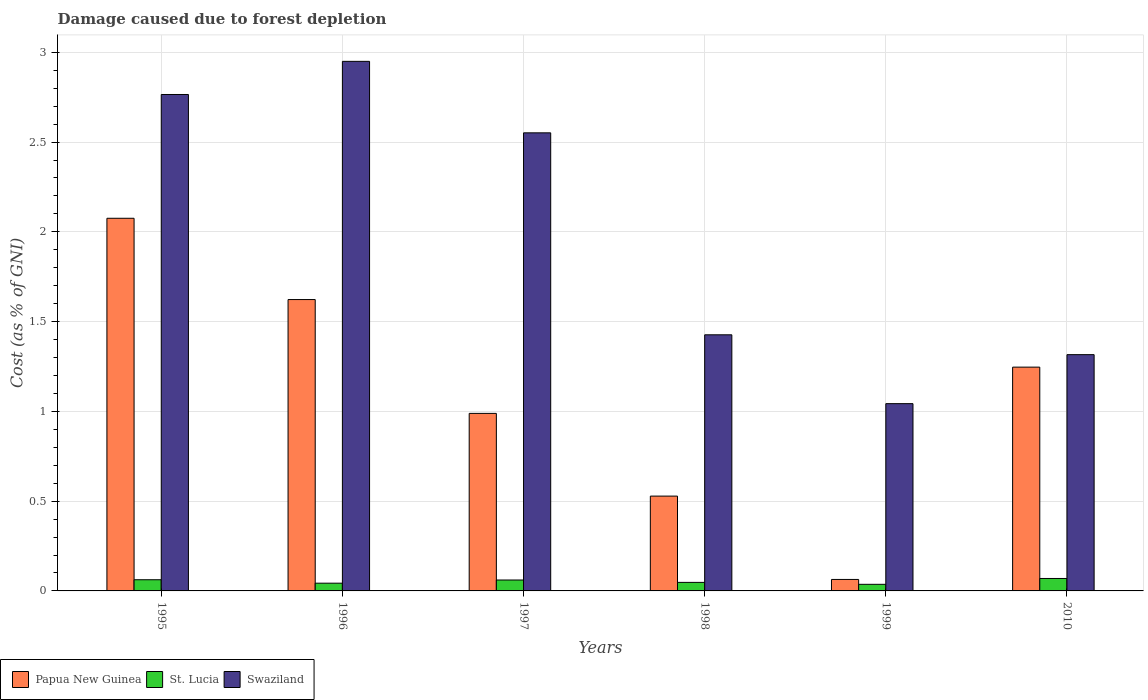How many different coloured bars are there?
Your answer should be compact. 3. How many groups of bars are there?
Keep it short and to the point. 6. Are the number of bars per tick equal to the number of legend labels?
Provide a short and direct response. Yes. How many bars are there on the 2nd tick from the left?
Your answer should be very brief. 3. How many bars are there on the 6th tick from the right?
Your answer should be compact. 3. What is the cost of damage caused due to forest depletion in Swaziland in 1997?
Give a very brief answer. 2.55. Across all years, what is the maximum cost of damage caused due to forest depletion in Swaziland?
Keep it short and to the point. 2.95. Across all years, what is the minimum cost of damage caused due to forest depletion in Swaziland?
Ensure brevity in your answer.  1.04. What is the total cost of damage caused due to forest depletion in Papua New Guinea in the graph?
Offer a very short reply. 6.53. What is the difference between the cost of damage caused due to forest depletion in Swaziland in 1996 and that in 1999?
Make the answer very short. 1.91. What is the difference between the cost of damage caused due to forest depletion in Swaziland in 1997 and the cost of damage caused due to forest depletion in Papua New Guinea in 1999?
Your response must be concise. 2.49. What is the average cost of damage caused due to forest depletion in St. Lucia per year?
Make the answer very short. 0.05. In the year 1996, what is the difference between the cost of damage caused due to forest depletion in Papua New Guinea and cost of damage caused due to forest depletion in Swaziland?
Provide a short and direct response. -1.33. In how many years, is the cost of damage caused due to forest depletion in Swaziland greater than 0.30000000000000004 %?
Provide a short and direct response. 6. What is the ratio of the cost of damage caused due to forest depletion in St. Lucia in 1998 to that in 2010?
Keep it short and to the point. 0.69. Is the cost of damage caused due to forest depletion in St. Lucia in 1997 less than that in 1999?
Keep it short and to the point. No. Is the difference between the cost of damage caused due to forest depletion in Papua New Guinea in 1995 and 1996 greater than the difference between the cost of damage caused due to forest depletion in Swaziland in 1995 and 1996?
Keep it short and to the point. Yes. What is the difference between the highest and the second highest cost of damage caused due to forest depletion in Swaziland?
Make the answer very short. 0.18. What is the difference between the highest and the lowest cost of damage caused due to forest depletion in Swaziland?
Your answer should be very brief. 1.91. In how many years, is the cost of damage caused due to forest depletion in Papua New Guinea greater than the average cost of damage caused due to forest depletion in Papua New Guinea taken over all years?
Make the answer very short. 3. Is the sum of the cost of damage caused due to forest depletion in St. Lucia in 1995 and 1996 greater than the maximum cost of damage caused due to forest depletion in Papua New Guinea across all years?
Offer a very short reply. No. What does the 2nd bar from the left in 1995 represents?
Your response must be concise. St. Lucia. What does the 1st bar from the right in 1996 represents?
Provide a short and direct response. Swaziland. How many bars are there?
Give a very brief answer. 18. What is the difference between two consecutive major ticks on the Y-axis?
Give a very brief answer. 0.5. Does the graph contain any zero values?
Provide a succinct answer. No. Does the graph contain grids?
Offer a very short reply. Yes. How are the legend labels stacked?
Provide a succinct answer. Horizontal. What is the title of the graph?
Your response must be concise. Damage caused due to forest depletion. What is the label or title of the Y-axis?
Provide a succinct answer. Cost (as % of GNI). What is the Cost (as % of GNI) in Papua New Guinea in 1995?
Your answer should be compact. 2.08. What is the Cost (as % of GNI) of St. Lucia in 1995?
Provide a short and direct response. 0.06. What is the Cost (as % of GNI) in Swaziland in 1995?
Ensure brevity in your answer.  2.77. What is the Cost (as % of GNI) in Papua New Guinea in 1996?
Ensure brevity in your answer.  1.62. What is the Cost (as % of GNI) of St. Lucia in 1996?
Provide a short and direct response. 0.04. What is the Cost (as % of GNI) in Swaziland in 1996?
Give a very brief answer. 2.95. What is the Cost (as % of GNI) of Papua New Guinea in 1997?
Ensure brevity in your answer.  0.99. What is the Cost (as % of GNI) of St. Lucia in 1997?
Offer a very short reply. 0.06. What is the Cost (as % of GNI) in Swaziland in 1997?
Provide a succinct answer. 2.55. What is the Cost (as % of GNI) in Papua New Guinea in 1998?
Your answer should be very brief. 0.53. What is the Cost (as % of GNI) of St. Lucia in 1998?
Give a very brief answer. 0.05. What is the Cost (as % of GNI) in Swaziland in 1998?
Ensure brevity in your answer.  1.43. What is the Cost (as % of GNI) of Papua New Guinea in 1999?
Your answer should be compact. 0.06. What is the Cost (as % of GNI) in St. Lucia in 1999?
Your answer should be compact. 0.04. What is the Cost (as % of GNI) in Swaziland in 1999?
Offer a very short reply. 1.04. What is the Cost (as % of GNI) in Papua New Guinea in 2010?
Your answer should be very brief. 1.25. What is the Cost (as % of GNI) in St. Lucia in 2010?
Your response must be concise. 0.07. What is the Cost (as % of GNI) of Swaziland in 2010?
Offer a terse response. 1.32. Across all years, what is the maximum Cost (as % of GNI) of Papua New Guinea?
Your answer should be compact. 2.08. Across all years, what is the maximum Cost (as % of GNI) in St. Lucia?
Offer a terse response. 0.07. Across all years, what is the maximum Cost (as % of GNI) in Swaziland?
Your answer should be compact. 2.95. Across all years, what is the minimum Cost (as % of GNI) of Papua New Guinea?
Your answer should be compact. 0.06. Across all years, what is the minimum Cost (as % of GNI) of St. Lucia?
Offer a very short reply. 0.04. Across all years, what is the minimum Cost (as % of GNI) of Swaziland?
Your answer should be compact. 1.04. What is the total Cost (as % of GNI) in Papua New Guinea in the graph?
Your response must be concise. 6.53. What is the total Cost (as % of GNI) in St. Lucia in the graph?
Make the answer very short. 0.32. What is the total Cost (as % of GNI) in Swaziland in the graph?
Provide a short and direct response. 12.05. What is the difference between the Cost (as % of GNI) of Papua New Guinea in 1995 and that in 1996?
Provide a succinct answer. 0.45. What is the difference between the Cost (as % of GNI) in St. Lucia in 1995 and that in 1996?
Keep it short and to the point. 0.02. What is the difference between the Cost (as % of GNI) of Swaziland in 1995 and that in 1996?
Provide a succinct answer. -0.18. What is the difference between the Cost (as % of GNI) in Papua New Guinea in 1995 and that in 1997?
Make the answer very short. 1.09. What is the difference between the Cost (as % of GNI) in St. Lucia in 1995 and that in 1997?
Make the answer very short. 0. What is the difference between the Cost (as % of GNI) of Swaziland in 1995 and that in 1997?
Offer a very short reply. 0.21. What is the difference between the Cost (as % of GNI) of Papua New Guinea in 1995 and that in 1998?
Offer a terse response. 1.55. What is the difference between the Cost (as % of GNI) of St. Lucia in 1995 and that in 1998?
Ensure brevity in your answer.  0.01. What is the difference between the Cost (as % of GNI) of Swaziland in 1995 and that in 1998?
Offer a terse response. 1.34. What is the difference between the Cost (as % of GNI) of Papua New Guinea in 1995 and that in 1999?
Offer a very short reply. 2.01. What is the difference between the Cost (as % of GNI) in St. Lucia in 1995 and that in 1999?
Offer a terse response. 0.03. What is the difference between the Cost (as % of GNI) of Swaziland in 1995 and that in 1999?
Give a very brief answer. 1.72. What is the difference between the Cost (as % of GNI) in Papua New Guinea in 1995 and that in 2010?
Your answer should be compact. 0.83. What is the difference between the Cost (as % of GNI) of St. Lucia in 1995 and that in 2010?
Offer a very short reply. -0.01. What is the difference between the Cost (as % of GNI) of Swaziland in 1995 and that in 2010?
Offer a terse response. 1.45. What is the difference between the Cost (as % of GNI) in Papua New Guinea in 1996 and that in 1997?
Ensure brevity in your answer.  0.63. What is the difference between the Cost (as % of GNI) of St. Lucia in 1996 and that in 1997?
Your response must be concise. -0.02. What is the difference between the Cost (as % of GNI) in Swaziland in 1996 and that in 1997?
Offer a very short reply. 0.4. What is the difference between the Cost (as % of GNI) in Papua New Guinea in 1996 and that in 1998?
Offer a very short reply. 1.09. What is the difference between the Cost (as % of GNI) of St. Lucia in 1996 and that in 1998?
Offer a very short reply. -0. What is the difference between the Cost (as % of GNI) of Swaziland in 1996 and that in 1998?
Offer a very short reply. 1.52. What is the difference between the Cost (as % of GNI) in Papua New Guinea in 1996 and that in 1999?
Provide a short and direct response. 1.56. What is the difference between the Cost (as % of GNI) of St. Lucia in 1996 and that in 1999?
Provide a short and direct response. 0.01. What is the difference between the Cost (as % of GNI) in Swaziland in 1996 and that in 1999?
Provide a succinct answer. 1.91. What is the difference between the Cost (as % of GNI) of Papua New Guinea in 1996 and that in 2010?
Your answer should be very brief. 0.38. What is the difference between the Cost (as % of GNI) in St. Lucia in 1996 and that in 2010?
Make the answer very short. -0.03. What is the difference between the Cost (as % of GNI) in Swaziland in 1996 and that in 2010?
Your answer should be compact. 1.63. What is the difference between the Cost (as % of GNI) of Papua New Guinea in 1997 and that in 1998?
Your answer should be compact. 0.46. What is the difference between the Cost (as % of GNI) in St. Lucia in 1997 and that in 1998?
Keep it short and to the point. 0.01. What is the difference between the Cost (as % of GNI) in Swaziland in 1997 and that in 1998?
Ensure brevity in your answer.  1.12. What is the difference between the Cost (as % of GNI) in Papua New Guinea in 1997 and that in 1999?
Make the answer very short. 0.92. What is the difference between the Cost (as % of GNI) of St. Lucia in 1997 and that in 1999?
Your answer should be very brief. 0.02. What is the difference between the Cost (as % of GNI) of Swaziland in 1997 and that in 1999?
Your response must be concise. 1.51. What is the difference between the Cost (as % of GNI) of Papua New Guinea in 1997 and that in 2010?
Your answer should be compact. -0.26. What is the difference between the Cost (as % of GNI) of St. Lucia in 1997 and that in 2010?
Provide a short and direct response. -0.01. What is the difference between the Cost (as % of GNI) of Swaziland in 1997 and that in 2010?
Provide a succinct answer. 1.24. What is the difference between the Cost (as % of GNI) of Papua New Guinea in 1998 and that in 1999?
Provide a short and direct response. 0.46. What is the difference between the Cost (as % of GNI) in St. Lucia in 1998 and that in 1999?
Provide a succinct answer. 0.01. What is the difference between the Cost (as % of GNI) of Swaziland in 1998 and that in 1999?
Ensure brevity in your answer.  0.38. What is the difference between the Cost (as % of GNI) in Papua New Guinea in 1998 and that in 2010?
Ensure brevity in your answer.  -0.72. What is the difference between the Cost (as % of GNI) in St. Lucia in 1998 and that in 2010?
Provide a short and direct response. -0.02. What is the difference between the Cost (as % of GNI) of Swaziland in 1998 and that in 2010?
Keep it short and to the point. 0.11. What is the difference between the Cost (as % of GNI) in Papua New Guinea in 1999 and that in 2010?
Keep it short and to the point. -1.18. What is the difference between the Cost (as % of GNI) in St. Lucia in 1999 and that in 2010?
Ensure brevity in your answer.  -0.03. What is the difference between the Cost (as % of GNI) in Swaziland in 1999 and that in 2010?
Make the answer very short. -0.27. What is the difference between the Cost (as % of GNI) of Papua New Guinea in 1995 and the Cost (as % of GNI) of St. Lucia in 1996?
Give a very brief answer. 2.03. What is the difference between the Cost (as % of GNI) of Papua New Guinea in 1995 and the Cost (as % of GNI) of Swaziland in 1996?
Your response must be concise. -0.87. What is the difference between the Cost (as % of GNI) in St. Lucia in 1995 and the Cost (as % of GNI) in Swaziland in 1996?
Offer a very short reply. -2.89. What is the difference between the Cost (as % of GNI) in Papua New Guinea in 1995 and the Cost (as % of GNI) in St. Lucia in 1997?
Give a very brief answer. 2.01. What is the difference between the Cost (as % of GNI) in Papua New Guinea in 1995 and the Cost (as % of GNI) in Swaziland in 1997?
Your answer should be compact. -0.48. What is the difference between the Cost (as % of GNI) in St. Lucia in 1995 and the Cost (as % of GNI) in Swaziland in 1997?
Your response must be concise. -2.49. What is the difference between the Cost (as % of GNI) of Papua New Guinea in 1995 and the Cost (as % of GNI) of St. Lucia in 1998?
Your answer should be compact. 2.03. What is the difference between the Cost (as % of GNI) in Papua New Guinea in 1995 and the Cost (as % of GNI) in Swaziland in 1998?
Give a very brief answer. 0.65. What is the difference between the Cost (as % of GNI) in St. Lucia in 1995 and the Cost (as % of GNI) in Swaziland in 1998?
Your answer should be very brief. -1.36. What is the difference between the Cost (as % of GNI) in Papua New Guinea in 1995 and the Cost (as % of GNI) in St. Lucia in 1999?
Make the answer very short. 2.04. What is the difference between the Cost (as % of GNI) in Papua New Guinea in 1995 and the Cost (as % of GNI) in Swaziland in 1999?
Give a very brief answer. 1.03. What is the difference between the Cost (as % of GNI) of St. Lucia in 1995 and the Cost (as % of GNI) of Swaziland in 1999?
Keep it short and to the point. -0.98. What is the difference between the Cost (as % of GNI) in Papua New Guinea in 1995 and the Cost (as % of GNI) in St. Lucia in 2010?
Keep it short and to the point. 2.01. What is the difference between the Cost (as % of GNI) of Papua New Guinea in 1995 and the Cost (as % of GNI) of Swaziland in 2010?
Your answer should be compact. 0.76. What is the difference between the Cost (as % of GNI) in St. Lucia in 1995 and the Cost (as % of GNI) in Swaziland in 2010?
Your answer should be compact. -1.25. What is the difference between the Cost (as % of GNI) of Papua New Guinea in 1996 and the Cost (as % of GNI) of St. Lucia in 1997?
Offer a terse response. 1.56. What is the difference between the Cost (as % of GNI) in Papua New Guinea in 1996 and the Cost (as % of GNI) in Swaziland in 1997?
Your response must be concise. -0.93. What is the difference between the Cost (as % of GNI) of St. Lucia in 1996 and the Cost (as % of GNI) of Swaziland in 1997?
Offer a very short reply. -2.51. What is the difference between the Cost (as % of GNI) of Papua New Guinea in 1996 and the Cost (as % of GNI) of St. Lucia in 1998?
Make the answer very short. 1.58. What is the difference between the Cost (as % of GNI) of Papua New Guinea in 1996 and the Cost (as % of GNI) of Swaziland in 1998?
Provide a short and direct response. 0.2. What is the difference between the Cost (as % of GNI) in St. Lucia in 1996 and the Cost (as % of GNI) in Swaziland in 1998?
Provide a succinct answer. -1.38. What is the difference between the Cost (as % of GNI) of Papua New Guinea in 1996 and the Cost (as % of GNI) of St. Lucia in 1999?
Your response must be concise. 1.59. What is the difference between the Cost (as % of GNI) of Papua New Guinea in 1996 and the Cost (as % of GNI) of Swaziland in 1999?
Your answer should be compact. 0.58. What is the difference between the Cost (as % of GNI) of Papua New Guinea in 1996 and the Cost (as % of GNI) of St. Lucia in 2010?
Keep it short and to the point. 1.55. What is the difference between the Cost (as % of GNI) in Papua New Guinea in 1996 and the Cost (as % of GNI) in Swaziland in 2010?
Make the answer very short. 0.31. What is the difference between the Cost (as % of GNI) in St. Lucia in 1996 and the Cost (as % of GNI) in Swaziland in 2010?
Provide a succinct answer. -1.27. What is the difference between the Cost (as % of GNI) of Papua New Guinea in 1997 and the Cost (as % of GNI) of St. Lucia in 1998?
Provide a short and direct response. 0.94. What is the difference between the Cost (as % of GNI) in Papua New Guinea in 1997 and the Cost (as % of GNI) in Swaziland in 1998?
Give a very brief answer. -0.44. What is the difference between the Cost (as % of GNI) in St. Lucia in 1997 and the Cost (as % of GNI) in Swaziland in 1998?
Offer a terse response. -1.37. What is the difference between the Cost (as % of GNI) of Papua New Guinea in 1997 and the Cost (as % of GNI) of St. Lucia in 1999?
Your response must be concise. 0.95. What is the difference between the Cost (as % of GNI) in Papua New Guinea in 1997 and the Cost (as % of GNI) in Swaziland in 1999?
Your answer should be very brief. -0.05. What is the difference between the Cost (as % of GNI) in St. Lucia in 1997 and the Cost (as % of GNI) in Swaziland in 1999?
Your answer should be very brief. -0.98. What is the difference between the Cost (as % of GNI) of Papua New Guinea in 1997 and the Cost (as % of GNI) of St. Lucia in 2010?
Provide a succinct answer. 0.92. What is the difference between the Cost (as % of GNI) in Papua New Guinea in 1997 and the Cost (as % of GNI) in Swaziland in 2010?
Your answer should be compact. -0.33. What is the difference between the Cost (as % of GNI) of St. Lucia in 1997 and the Cost (as % of GNI) of Swaziland in 2010?
Keep it short and to the point. -1.26. What is the difference between the Cost (as % of GNI) of Papua New Guinea in 1998 and the Cost (as % of GNI) of St. Lucia in 1999?
Ensure brevity in your answer.  0.49. What is the difference between the Cost (as % of GNI) in Papua New Guinea in 1998 and the Cost (as % of GNI) in Swaziland in 1999?
Your response must be concise. -0.51. What is the difference between the Cost (as % of GNI) in St. Lucia in 1998 and the Cost (as % of GNI) in Swaziland in 1999?
Make the answer very short. -1. What is the difference between the Cost (as % of GNI) in Papua New Guinea in 1998 and the Cost (as % of GNI) in St. Lucia in 2010?
Ensure brevity in your answer.  0.46. What is the difference between the Cost (as % of GNI) of Papua New Guinea in 1998 and the Cost (as % of GNI) of Swaziland in 2010?
Ensure brevity in your answer.  -0.79. What is the difference between the Cost (as % of GNI) of St. Lucia in 1998 and the Cost (as % of GNI) of Swaziland in 2010?
Ensure brevity in your answer.  -1.27. What is the difference between the Cost (as % of GNI) of Papua New Guinea in 1999 and the Cost (as % of GNI) of St. Lucia in 2010?
Provide a short and direct response. -0.01. What is the difference between the Cost (as % of GNI) in Papua New Guinea in 1999 and the Cost (as % of GNI) in Swaziland in 2010?
Keep it short and to the point. -1.25. What is the difference between the Cost (as % of GNI) in St. Lucia in 1999 and the Cost (as % of GNI) in Swaziland in 2010?
Your answer should be very brief. -1.28. What is the average Cost (as % of GNI) of Papua New Guinea per year?
Your answer should be very brief. 1.09. What is the average Cost (as % of GNI) of St. Lucia per year?
Your response must be concise. 0.05. What is the average Cost (as % of GNI) of Swaziland per year?
Keep it short and to the point. 2.01. In the year 1995, what is the difference between the Cost (as % of GNI) of Papua New Guinea and Cost (as % of GNI) of St. Lucia?
Give a very brief answer. 2.01. In the year 1995, what is the difference between the Cost (as % of GNI) of Papua New Guinea and Cost (as % of GNI) of Swaziland?
Give a very brief answer. -0.69. In the year 1995, what is the difference between the Cost (as % of GNI) in St. Lucia and Cost (as % of GNI) in Swaziland?
Make the answer very short. -2.7. In the year 1996, what is the difference between the Cost (as % of GNI) in Papua New Guinea and Cost (as % of GNI) in St. Lucia?
Offer a terse response. 1.58. In the year 1996, what is the difference between the Cost (as % of GNI) of Papua New Guinea and Cost (as % of GNI) of Swaziland?
Offer a terse response. -1.33. In the year 1996, what is the difference between the Cost (as % of GNI) in St. Lucia and Cost (as % of GNI) in Swaziland?
Your answer should be compact. -2.91. In the year 1997, what is the difference between the Cost (as % of GNI) of Papua New Guinea and Cost (as % of GNI) of St. Lucia?
Make the answer very short. 0.93. In the year 1997, what is the difference between the Cost (as % of GNI) in Papua New Guinea and Cost (as % of GNI) in Swaziland?
Give a very brief answer. -1.56. In the year 1997, what is the difference between the Cost (as % of GNI) in St. Lucia and Cost (as % of GNI) in Swaziland?
Your answer should be very brief. -2.49. In the year 1998, what is the difference between the Cost (as % of GNI) of Papua New Guinea and Cost (as % of GNI) of St. Lucia?
Provide a succinct answer. 0.48. In the year 1998, what is the difference between the Cost (as % of GNI) of Papua New Guinea and Cost (as % of GNI) of Swaziland?
Offer a terse response. -0.9. In the year 1998, what is the difference between the Cost (as % of GNI) of St. Lucia and Cost (as % of GNI) of Swaziland?
Make the answer very short. -1.38. In the year 1999, what is the difference between the Cost (as % of GNI) in Papua New Guinea and Cost (as % of GNI) in St. Lucia?
Ensure brevity in your answer.  0.03. In the year 1999, what is the difference between the Cost (as % of GNI) in Papua New Guinea and Cost (as % of GNI) in Swaziland?
Offer a terse response. -0.98. In the year 1999, what is the difference between the Cost (as % of GNI) of St. Lucia and Cost (as % of GNI) of Swaziland?
Offer a terse response. -1.01. In the year 2010, what is the difference between the Cost (as % of GNI) in Papua New Guinea and Cost (as % of GNI) in St. Lucia?
Offer a very short reply. 1.18. In the year 2010, what is the difference between the Cost (as % of GNI) of Papua New Guinea and Cost (as % of GNI) of Swaziland?
Make the answer very short. -0.07. In the year 2010, what is the difference between the Cost (as % of GNI) of St. Lucia and Cost (as % of GNI) of Swaziland?
Provide a succinct answer. -1.25. What is the ratio of the Cost (as % of GNI) in Papua New Guinea in 1995 to that in 1996?
Make the answer very short. 1.28. What is the ratio of the Cost (as % of GNI) of St. Lucia in 1995 to that in 1996?
Your answer should be compact. 1.44. What is the ratio of the Cost (as % of GNI) in Swaziland in 1995 to that in 1996?
Provide a succinct answer. 0.94. What is the ratio of the Cost (as % of GNI) of Papua New Guinea in 1995 to that in 1997?
Ensure brevity in your answer.  2.1. What is the ratio of the Cost (as % of GNI) of St. Lucia in 1995 to that in 1997?
Give a very brief answer. 1.02. What is the ratio of the Cost (as % of GNI) in Swaziland in 1995 to that in 1997?
Keep it short and to the point. 1.08. What is the ratio of the Cost (as % of GNI) in Papua New Guinea in 1995 to that in 1998?
Give a very brief answer. 3.93. What is the ratio of the Cost (as % of GNI) of St. Lucia in 1995 to that in 1998?
Keep it short and to the point. 1.31. What is the ratio of the Cost (as % of GNI) of Swaziland in 1995 to that in 1998?
Your response must be concise. 1.94. What is the ratio of the Cost (as % of GNI) of Papua New Guinea in 1995 to that in 1999?
Provide a succinct answer. 32.46. What is the ratio of the Cost (as % of GNI) in St. Lucia in 1995 to that in 1999?
Offer a very short reply. 1.69. What is the ratio of the Cost (as % of GNI) in Swaziland in 1995 to that in 1999?
Your response must be concise. 2.65. What is the ratio of the Cost (as % of GNI) in Papua New Guinea in 1995 to that in 2010?
Ensure brevity in your answer.  1.67. What is the ratio of the Cost (as % of GNI) in St. Lucia in 1995 to that in 2010?
Give a very brief answer. 0.9. What is the ratio of the Cost (as % of GNI) of Swaziland in 1995 to that in 2010?
Provide a short and direct response. 2.1. What is the ratio of the Cost (as % of GNI) of Papua New Guinea in 1996 to that in 1997?
Your answer should be very brief. 1.64. What is the ratio of the Cost (as % of GNI) in St. Lucia in 1996 to that in 1997?
Keep it short and to the point. 0.71. What is the ratio of the Cost (as % of GNI) in Swaziland in 1996 to that in 1997?
Offer a terse response. 1.16. What is the ratio of the Cost (as % of GNI) in Papua New Guinea in 1996 to that in 1998?
Offer a terse response. 3.07. What is the ratio of the Cost (as % of GNI) in St. Lucia in 1996 to that in 1998?
Provide a succinct answer. 0.91. What is the ratio of the Cost (as % of GNI) of Swaziland in 1996 to that in 1998?
Your answer should be compact. 2.07. What is the ratio of the Cost (as % of GNI) of Papua New Guinea in 1996 to that in 1999?
Provide a succinct answer. 25.38. What is the ratio of the Cost (as % of GNI) in St. Lucia in 1996 to that in 1999?
Ensure brevity in your answer.  1.17. What is the ratio of the Cost (as % of GNI) of Swaziland in 1996 to that in 1999?
Offer a very short reply. 2.83. What is the ratio of the Cost (as % of GNI) of Papua New Guinea in 1996 to that in 2010?
Your response must be concise. 1.3. What is the ratio of the Cost (as % of GNI) of St. Lucia in 1996 to that in 2010?
Your answer should be very brief. 0.62. What is the ratio of the Cost (as % of GNI) of Swaziland in 1996 to that in 2010?
Your answer should be compact. 2.24. What is the ratio of the Cost (as % of GNI) of Papua New Guinea in 1997 to that in 1998?
Make the answer very short. 1.87. What is the ratio of the Cost (as % of GNI) in St. Lucia in 1997 to that in 1998?
Your answer should be very brief. 1.28. What is the ratio of the Cost (as % of GNI) in Swaziland in 1997 to that in 1998?
Make the answer very short. 1.79. What is the ratio of the Cost (as % of GNI) of Papua New Guinea in 1997 to that in 1999?
Give a very brief answer. 15.46. What is the ratio of the Cost (as % of GNI) in St. Lucia in 1997 to that in 1999?
Your answer should be very brief. 1.65. What is the ratio of the Cost (as % of GNI) in Swaziland in 1997 to that in 1999?
Your answer should be compact. 2.45. What is the ratio of the Cost (as % of GNI) of Papua New Guinea in 1997 to that in 2010?
Ensure brevity in your answer.  0.79. What is the ratio of the Cost (as % of GNI) in St. Lucia in 1997 to that in 2010?
Make the answer very short. 0.88. What is the ratio of the Cost (as % of GNI) in Swaziland in 1997 to that in 2010?
Keep it short and to the point. 1.94. What is the ratio of the Cost (as % of GNI) in Papua New Guinea in 1998 to that in 1999?
Your answer should be very brief. 8.26. What is the ratio of the Cost (as % of GNI) of St. Lucia in 1998 to that in 1999?
Offer a very short reply. 1.29. What is the ratio of the Cost (as % of GNI) of Swaziland in 1998 to that in 1999?
Provide a short and direct response. 1.37. What is the ratio of the Cost (as % of GNI) of Papua New Guinea in 1998 to that in 2010?
Offer a terse response. 0.42. What is the ratio of the Cost (as % of GNI) of St. Lucia in 1998 to that in 2010?
Give a very brief answer. 0.69. What is the ratio of the Cost (as % of GNI) of Swaziland in 1998 to that in 2010?
Keep it short and to the point. 1.08. What is the ratio of the Cost (as % of GNI) in Papua New Guinea in 1999 to that in 2010?
Give a very brief answer. 0.05. What is the ratio of the Cost (as % of GNI) of St. Lucia in 1999 to that in 2010?
Your answer should be very brief. 0.53. What is the ratio of the Cost (as % of GNI) of Swaziland in 1999 to that in 2010?
Offer a very short reply. 0.79. What is the difference between the highest and the second highest Cost (as % of GNI) of Papua New Guinea?
Offer a terse response. 0.45. What is the difference between the highest and the second highest Cost (as % of GNI) in St. Lucia?
Make the answer very short. 0.01. What is the difference between the highest and the second highest Cost (as % of GNI) of Swaziland?
Your answer should be compact. 0.18. What is the difference between the highest and the lowest Cost (as % of GNI) in Papua New Guinea?
Make the answer very short. 2.01. What is the difference between the highest and the lowest Cost (as % of GNI) of St. Lucia?
Provide a succinct answer. 0.03. What is the difference between the highest and the lowest Cost (as % of GNI) in Swaziland?
Offer a terse response. 1.91. 